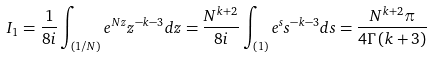Convert formula to latex. <formula><loc_0><loc_0><loc_500><loc_500>I _ { 1 } = \frac { 1 } { 8 i } \int _ { \left ( 1 / N \right ) } e ^ { N z } z ^ { - k - 3 } d z = \frac { N ^ { k + 2 } } { 8 i } \int _ { \left ( 1 \right ) } e ^ { s } s ^ { - k - 3 } d s = \frac { N ^ { k + 2 } \pi } { 4 \Gamma \left ( k + 3 \right ) }</formula> 